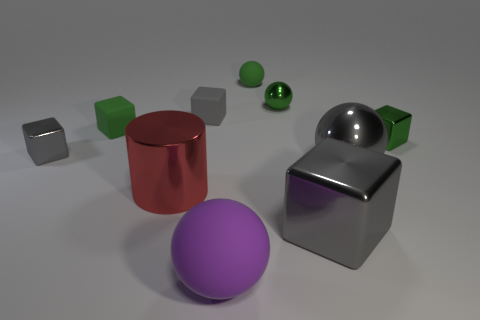Are there any gray rubber objects that have the same shape as the small gray shiny object?
Give a very brief answer. Yes. How many green metallic things have the same shape as the red metallic thing?
Offer a terse response. 0. Does the large block have the same color as the large metal sphere?
Your answer should be compact. Yes. Is the number of big metallic objects less than the number of large green metallic things?
Offer a very short reply. No. There is a small green object that is left of the big rubber object; what is its material?
Your answer should be very brief. Rubber. What is the material of the purple object that is the same size as the red object?
Offer a terse response. Rubber. There is a big sphere that is to the left of the large cube that is right of the tiny gray cube on the right side of the small gray metal cube; what is its material?
Offer a very short reply. Rubber. There is a gray metallic ball that is behind the red thing; is its size the same as the big rubber sphere?
Ensure brevity in your answer.  Yes. Are there more big purple cubes than tiny green blocks?
Your answer should be compact. No. How many small things are metallic blocks or red objects?
Give a very brief answer. 2. 